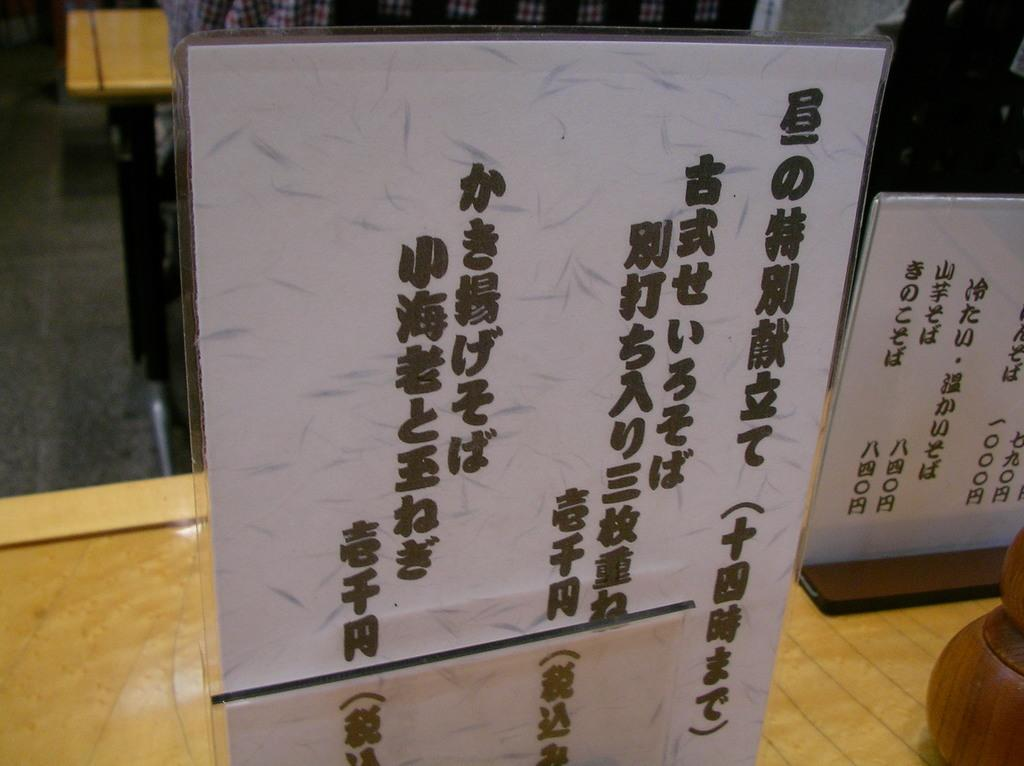What can be seen in the image related to advertising? There are advertisement boards in the image. Where are the advertisement boards located? The advertisement boards are placed on a table. Reasoning: Let' Let's think step by step in order to produce the conversation. We start by identifying the main subject in the image, which is the advertisement boards. Then, we expand the conversation to include the location of the advertisement boards, which is on a table. Each question is designed to elicit a specific detail about the image that is known from the provided facts. Absurd Question/Answer: What type of library is depicted on the advertisement boards? There is no library depicted on the advertisement boards; they are simply advertisement boards placed on a table. 